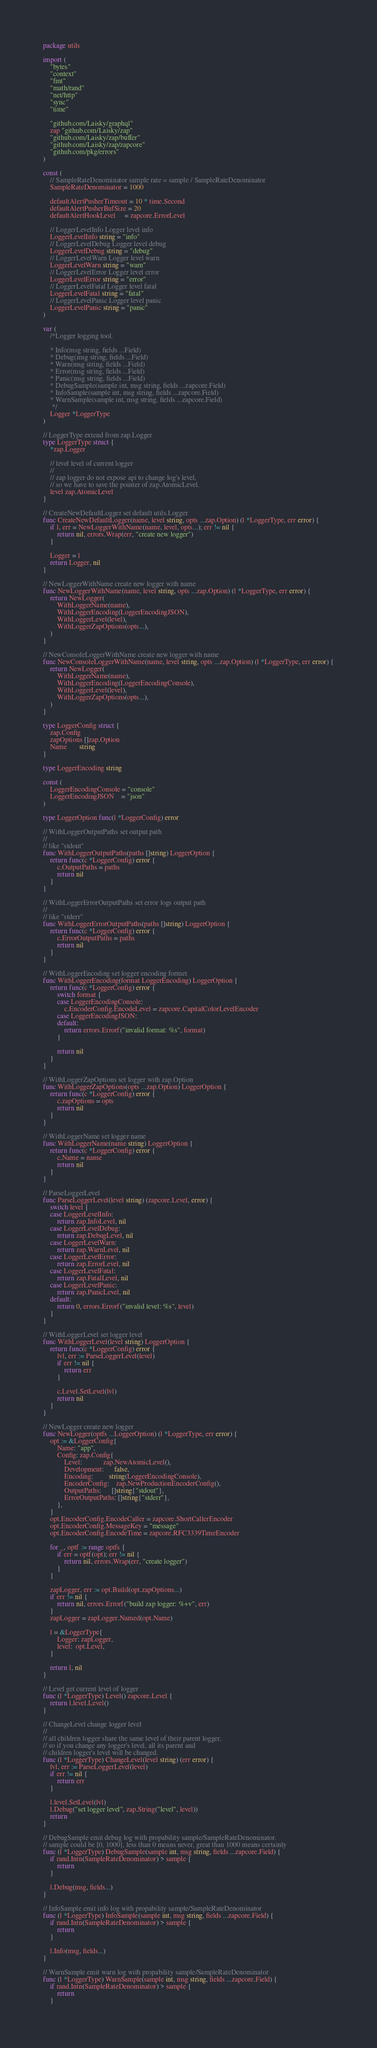<code> <loc_0><loc_0><loc_500><loc_500><_Go_>package utils

import (
	"bytes"
	"context"
	"fmt"
	"math/rand"
	"net/http"
	"sync"
	"time"

	"github.com/Laisky/graphql"
	zap "github.com/Laisky/zap"
	"github.com/Laisky/zap/buffer"
	"github.com/Laisky/zap/zapcore"
	"github.com/pkg/errors"
)

const (
	// SampleRateDenominator sample rate = sample / SampleRateDenominator
	SampleRateDenominator = 1000

	defaultAlertPusherTimeout = 10 * time.Second
	defaultAlertPusherBufSize = 20
	defaultAlertHookLevel     = zapcore.ErrorLevel

	// LoggerLevelInfo Logger level info
	LoggerLevelInfo string = "info"
	// LoggerLevelDebug Logger level debug
	LoggerLevelDebug string = "debug"
	// LoggerLevelWarn Logger level warn
	LoggerLevelWarn string = "warn"
	// LoggerLevelError Logger level error
	LoggerLevelError string = "error"
	// LoggerLevelFatal Logger level fatal
	LoggerLevelFatal string = "fatal"
	// LoggerLevelPanic Logger level panic
	LoggerLevelPanic string = "panic"
)

var (
	/*Logger logging tool.

	* Info(msg string, fields ...Field)
	* Debug(msg string, fields ...Field)
	* Warn(msg string, fields ...Field)
	* Error(msg string, fields ...Field)
	* Panic(msg string, fields ...Field)
	* DebugSample(sample int, msg string, fields ...zapcore.Field)
	* InfoSample(sample int, msg string, fields ...zapcore.Field)
	* WarnSample(sample int, msg string, fields ...zapcore.Field)
	 */
	Logger *LoggerType
)

// LoggerType extend from zap.Logger
type LoggerType struct {
	*zap.Logger

	// level level of current logger
	//
	// zap logger do not expose api to change log's level,
	// so we have to save the pointer of zap.AtomicLevel.
	level zap.AtomicLevel
}

// CreateNewDefaultLogger set default utils.Logger
func CreateNewDefaultLogger(name, level string, opts ...zap.Option) (l *LoggerType, err error) {
	if l, err = NewLoggerWithName(name, level, opts...); err != nil {
		return nil, errors.Wrap(err, "create new logger")
	}

	Logger = l
	return Logger, nil
}

// NewLoggerWithName create new logger with name
func NewLoggerWithName(name, level string, opts ...zap.Option) (l *LoggerType, err error) {
	return NewLogger(
		WithLoggerName(name),
		WithLoggerEncoding(LoggerEncodingJSON),
		WithLoggerLevel(level),
		WithLoggerZapOptions(opts...),
	)
}

// NewConsoleLoggerWithName create new logger with name
func NewConsoleLoggerWithName(name, level string, opts ...zap.Option) (l *LoggerType, err error) {
	return NewLogger(
		WithLoggerName(name),
		WithLoggerEncoding(LoggerEncodingConsole),
		WithLoggerLevel(level),
		WithLoggerZapOptions(opts...),
	)
}

type LoggerConfig struct {
	zap.Config
	zapOptions []zap.Option
	Name       string
}

type LoggerEncoding string

const (
	LoggerEncodingConsole = "console"
	LoggerEncodingJSON    = "json"
)

type LoggerOption func(l *LoggerConfig) error

// WithLoggerOutputPaths set output path
//
// like "stdout"
func WithLoggerOutputPaths(paths []string) LoggerOption {
	return func(c *LoggerConfig) error {
		c.OutputPaths = paths
		return nil
	}
}

// WithLoggerErrorOutputPaths set error logs output path
//
// like "stderr"
func WithLoggerErrorOutputPaths(paths []string) LoggerOption {
	return func(c *LoggerConfig) error {
		c.ErrorOutputPaths = paths
		return nil
	}
}

// WithLoggerEncoding set logger encoding formet
func WithLoggerEncoding(format LoggerEncoding) LoggerOption {
	return func(c *LoggerConfig) error {
		switch format {
		case LoggerEncodingConsole:
			c.EncoderConfig.EncodeLevel = zapcore.CapitalColorLevelEncoder
		case LoggerEncodingJSON:
		default:
			return errors.Errorf("invalid format: %s", format)
		}

		return nil
	}
}

// WithLoggerZapOptions set logger with zap.Option
func WithLoggerZapOptions(opts ...zap.Option) LoggerOption {
	return func(c *LoggerConfig) error {
		c.zapOptions = opts
		return nil
	}
}

// WithLoggerName set logger name
func WithLoggerName(name string) LoggerOption {
	return func(c *LoggerConfig) error {
		c.Name = name
		return nil
	}
}

// ParseLoggerLevel
func ParseLoggerLevel(level string) (zapcore.Level, error) {
	switch level {
	case LoggerLevelInfo:
		return zap.InfoLevel, nil
	case LoggerLevelDebug:
		return zap.DebugLevel, nil
	case LoggerLevelWarn:
		return zap.WarnLevel, nil
	case LoggerLevelError:
		return zap.ErrorLevel, nil
	case LoggerLevelFatal:
		return zap.FatalLevel, nil
	case LoggerLevelPanic:
		return zap.PanicLevel, nil
	default:
		return 0, errors.Errorf("invalid level: %s", level)
	}
}

// WithLoggerLevel set logger level
func WithLoggerLevel(level string) LoggerOption {
	return func(c *LoggerConfig) error {
		lvl, err := ParseLoggerLevel(level)
		if err != nil {
			return err
		}

		c.Level.SetLevel(lvl)
		return nil
	}
}

// NewLogger create new logger
func NewLogger(optfs ...LoggerOption) (l *LoggerType, err error) {
	opt := &LoggerConfig{
		Name: "app",
		Config: zap.Config{
			Level:            zap.NewAtomicLevel(),
			Development:      false,
			Encoding:         string(LoggerEncodingConsole),
			EncoderConfig:    zap.NewProductionEncoderConfig(),
			OutputPaths:      []string{"stdout"},
			ErrorOutputPaths: []string{"stderr"},
		},
	}
	opt.EncoderConfig.EncodeCaller = zapcore.ShortCallerEncoder
	opt.EncoderConfig.MessageKey = "message"
	opt.EncoderConfig.EncodeTime = zapcore.RFC3339TimeEncoder

	for _, optf := range optfs {
		if err = optf(opt); err != nil {
			return nil, errors.Wrap(err, "create logger")
		}
	}

	zapLogger, err := opt.Build(opt.zapOptions...)
	if err != nil {
		return nil, errors.Errorf("build zap logger: %+v", err)
	}
	zapLogger = zapLogger.Named(opt.Name)

	l = &LoggerType{
		Logger: zapLogger,
		level:  opt.Level,
	}

	return l, nil
}

// Level get current level of logger
func (l *LoggerType) Level() zapcore.Level {
	return l.level.Level()
}

// ChangeLevel change logger level
//
// all children logger share the same level of their parent logger,
// so if you change any logger's level, all its parent and
// children logger's level will be changed.
func (l *LoggerType) ChangeLevel(level string) (err error) {
	lvl, err := ParseLoggerLevel(level)
	if err != nil {
		return err
	}

	l.level.SetLevel(lvl)
	l.Debug("set logger level", zap.String("level", level))
	return
}

// DebugSample emit debug log with propability sample/SampleRateDenominator.
// sample could be [0, 1000], less than 0 means never, great than 1000 means certainly
func (l *LoggerType) DebugSample(sample int, msg string, fields ...zapcore.Field) {
	if rand.Intn(SampleRateDenominator) > sample {
		return
	}

	l.Debug(msg, fields...)
}

// InfoSample emit info log with propability sample/SampleRateDenominator
func (l *LoggerType) InfoSample(sample int, msg string, fields ...zapcore.Field) {
	if rand.Intn(SampleRateDenominator) > sample {
		return
	}

	l.Info(msg, fields...)
}

// WarnSample emit warn log with propability sample/SampleRateDenominator
func (l *LoggerType) WarnSample(sample int, msg string, fields ...zapcore.Field) {
	if rand.Intn(SampleRateDenominator) > sample {
		return
	}
</code> 